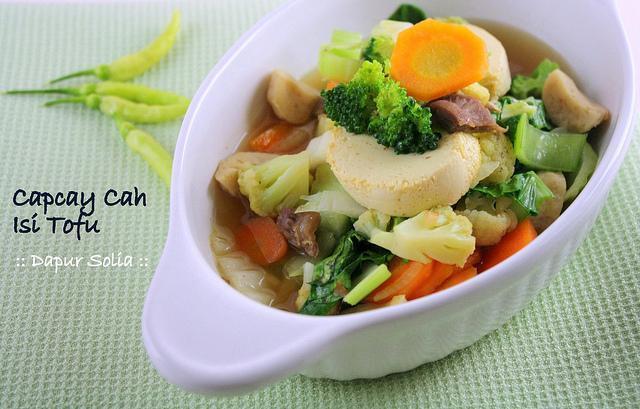How many bowls are there?
Give a very brief answer. 1. How many broccolis are there?
Give a very brief answer. 4. How many carrots are visible?
Give a very brief answer. 2. How many umbrellas have more than 4 colors?
Give a very brief answer. 0. 